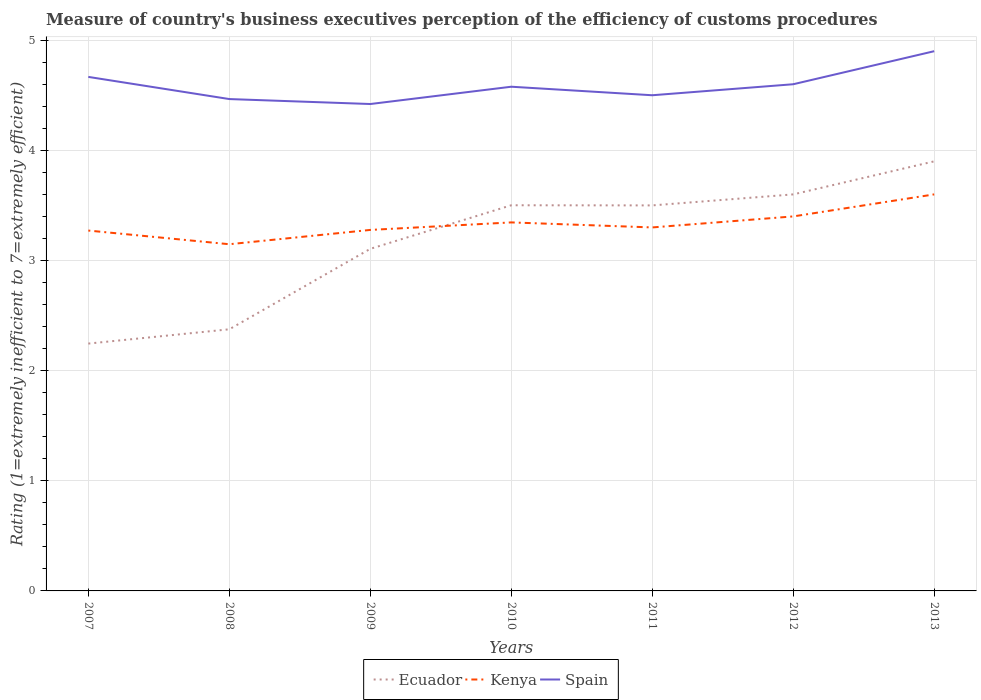How many different coloured lines are there?
Your answer should be compact. 3. Across all years, what is the maximum rating of the efficiency of customs procedure in Ecuador?
Your response must be concise. 2.25. What is the total rating of the efficiency of customs procedure in Spain in the graph?
Your answer should be compact. -0.02. What is the difference between the highest and the second highest rating of the efficiency of customs procedure in Spain?
Offer a very short reply. 0.48. Is the rating of the efficiency of customs procedure in Ecuador strictly greater than the rating of the efficiency of customs procedure in Spain over the years?
Keep it short and to the point. Yes. What is the difference between two consecutive major ticks on the Y-axis?
Provide a succinct answer. 1. Are the values on the major ticks of Y-axis written in scientific E-notation?
Your answer should be very brief. No. Does the graph contain any zero values?
Provide a succinct answer. No. Does the graph contain grids?
Make the answer very short. Yes. Where does the legend appear in the graph?
Provide a short and direct response. Bottom center. What is the title of the graph?
Provide a short and direct response. Measure of country's business executives perception of the efficiency of customs procedures. What is the label or title of the Y-axis?
Your answer should be very brief. Rating (1=extremely inefficient to 7=extremely efficient). What is the Rating (1=extremely inefficient to 7=extremely efficient) of Ecuador in 2007?
Give a very brief answer. 2.25. What is the Rating (1=extremely inefficient to 7=extremely efficient) in Kenya in 2007?
Your response must be concise. 3.27. What is the Rating (1=extremely inefficient to 7=extremely efficient) in Spain in 2007?
Your answer should be very brief. 4.67. What is the Rating (1=extremely inefficient to 7=extremely efficient) of Ecuador in 2008?
Provide a short and direct response. 2.38. What is the Rating (1=extremely inefficient to 7=extremely efficient) in Kenya in 2008?
Provide a succinct answer. 3.15. What is the Rating (1=extremely inefficient to 7=extremely efficient) of Spain in 2008?
Your answer should be very brief. 4.47. What is the Rating (1=extremely inefficient to 7=extremely efficient) of Ecuador in 2009?
Offer a very short reply. 3.11. What is the Rating (1=extremely inefficient to 7=extremely efficient) of Kenya in 2009?
Provide a succinct answer. 3.28. What is the Rating (1=extremely inefficient to 7=extremely efficient) in Spain in 2009?
Offer a very short reply. 4.42. What is the Rating (1=extremely inefficient to 7=extremely efficient) of Ecuador in 2010?
Your answer should be compact. 3.5. What is the Rating (1=extremely inefficient to 7=extremely efficient) of Kenya in 2010?
Your answer should be compact. 3.35. What is the Rating (1=extremely inefficient to 7=extremely efficient) of Spain in 2010?
Offer a very short reply. 4.58. What is the Rating (1=extremely inefficient to 7=extremely efficient) in Kenya in 2011?
Your answer should be very brief. 3.3. What is the Rating (1=extremely inefficient to 7=extremely efficient) of Spain in 2011?
Ensure brevity in your answer.  4.5. What is the Rating (1=extremely inefficient to 7=extremely efficient) in Ecuador in 2012?
Offer a very short reply. 3.6. What is the Rating (1=extremely inefficient to 7=extremely efficient) in Spain in 2013?
Your response must be concise. 4.9. Across all years, what is the maximum Rating (1=extremely inefficient to 7=extremely efficient) of Spain?
Provide a succinct answer. 4.9. Across all years, what is the minimum Rating (1=extremely inefficient to 7=extremely efficient) of Ecuador?
Make the answer very short. 2.25. Across all years, what is the minimum Rating (1=extremely inefficient to 7=extremely efficient) in Kenya?
Your answer should be compact. 3.15. Across all years, what is the minimum Rating (1=extremely inefficient to 7=extremely efficient) of Spain?
Your answer should be compact. 4.42. What is the total Rating (1=extremely inefficient to 7=extremely efficient) in Ecuador in the graph?
Your response must be concise. 22.23. What is the total Rating (1=extremely inefficient to 7=extremely efficient) of Kenya in the graph?
Your response must be concise. 23.34. What is the total Rating (1=extremely inefficient to 7=extremely efficient) in Spain in the graph?
Keep it short and to the point. 32.13. What is the difference between the Rating (1=extremely inefficient to 7=extremely efficient) in Ecuador in 2007 and that in 2008?
Offer a terse response. -0.13. What is the difference between the Rating (1=extremely inefficient to 7=extremely efficient) in Kenya in 2007 and that in 2008?
Your answer should be compact. 0.12. What is the difference between the Rating (1=extremely inefficient to 7=extremely efficient) of Spain in 2007 and that in 2008?
Provide a succinct answer. 0.2. What is the difference between the Rating (1=extremely inefficient to 7=extremely efficient) in Ecuador in 2007 and that in 2009?
Provide a short and direct response. -0.86. What is the difference between the Rating (1=extremely inefficient to 7=extremely efficient) of Kenya in 2007 and that in 2009?
Ensure brevity in your answer.  -0.01. What is the difference between the Rating (1=extremely inefficient to 7=extremely efficient) in Spain in 2007 and that in 2009?
Your answer should be compact. 0.25. What is the difference between the Rating (1=extremely inefficient to 7=extremely efficient) of Ecuador in 2007 and that in 2010?
Offer a very short reply. -1.26. What is the difference between the Rating (1=extremely inefficient to 7=extremely efficient) of Kenya in 2007 and that in 2010?
Your answer should be very brief. -0.07. What is the difference between the Rating (1=extremely inefficient to 7=extremely efficient) of Spain in 2007 and that in 2010?
Provide a succinct answer. 0.09. What is the difference between the Rating (1=extremely inefficient to 7=extremely efficient) in Ecuador in 2007 and that in 2011?
Your answer should be compact. -1.25. What is the difference between the Rating (1=extremely inefficient to 7=extremely efficient) of Kenya in 2007 and that in 2011?
Give a very brief answer. -0.03. What is the difference between the Rating (1=extremely inefficient to 7=extremely efficient) in Ecuador in 2007 and that in 2012?
Offer a terse response. -1.35. What is the difference between the Rating (1=extremely inefficient to 7=extremely efficient) in Kenya in 2007 and that in 2012?
Your answer should be compact. -0.13. What is the difference between the Rating (1=extremely inefficient to 7=extremely efficient) in Spain in 2007 and that in 2012?
Make the answer very short. 0.07. What is the difference between the Rating (1=extremely inefficient to 7=extremely efficient) of Ecuador in 2007 and that in 2013?
Ensure brevity in your answer.  -1.65. What is the difference between the Rating (1=extremely inefficient to 7=extremely efficient) of Kenya in 2007 and that in 2013?
Offer a very short reply. -0.33. What is the difference between the Rating (1=extremely inefficient to 7=extremely efficient) in Spain in 2007 and that in 2013?
Give a very brief answer. -0.23. What is the difference between the Rating (1=extremely inefficient to 7=extremely efficient) in Ecuador in 2008 and that in 2009?
Give a very brief answer. -0.73. What is the difference between the Rating (1=extremely inefficient to 7=extremely efficient) of Kenya in 2008 and that in 2009?
Offer a very short reply. -0.13. What is the difference between the Rating (1=extremely inefficient to 7=extremely efficient) of Spain in 2008 and that in 2009?
Ensure brevity in your answer.  0.05. What is the difference between the Rating (1=extremely inefficient to 7=extremely efficient) of Ecuador in 2008 and that in 2010?
Offer a very short reply. -1.13. What is the difference between the Rating (1=extremely inefficient to 7=extremely efficient) of Kenya in 2008 and that in 2010?
Offer a terse response. -0.2. What is the difference between the Rating (1=extremely inefficient to 7=extremely efficient) in Spain in 2008 and that in 2010?
Your response must be concise. -0.11. What is the difference between the Rating (1=extremely inefficient to 7=extremely efficient) in Ecuador in 2008 and that in 2011?
Keep it short and to the point. -1.12. What is the difference between the Rating (1=extremely inefficient to 7=extremely efficient) of Kenya in 2008 and that in 2011?
Ensure brevity in your answer.  -0.15. What is the difference between the Rating (1=extremely inefficient to 7=extremely efficient) in Spain in 2008 and that in 2011?
Offer a very short reply. -0.03. What is the difference between the Rating (1=extremely inefficient to 7=extremely efficient) in Ecuador in 2008 and that in 2012?
Your response must be concise. -1.22. What is the difference between the Rating (1=extremely inefficient to 7=extremely efficient) of Kenya in 2008 and that in 2012?
Offer a terse response. -0.25. What is the difference between the Rating (1=extremely inefficient to 7=extremely efficient) in Spain in 2008 and that in 2012?
Ensure brevity in your answer.  -0.13. What is the difference between the Rating (1=extremely inefficient to 7=extremely efficient) in Ecuador in 2008 and that in 2013?
Provide a succinct answer. -1.52. What is the difference between the Rating (1=extremely inefficient to 7=extremely efficient) in Kenya in 2008 and that in 2013?
Offer a terse response. -0.45. What is the difference between the Rating (1=extremely inefficient to 7=extremely efficient) of Spain in 2008 and that in 2013?
Make the answer very short. -0.43. What is the difference between the Rating (1=extremely inefficient to 7=extremely efficient) of Ecuador in 2009 and that in 2010?
Make the answer very short. -0.4. What is the difference between the Rating (1=extremely inefficient to 7=extremely efficient) in Kenya in 2009 and that in 2010?
Make the answer very short. -0.07. What is the difference between the Rating (1=extremely inefficient to 7=extremely efficient) of Spain in 2009 and that in 2010?
Offer a terse response. -0.16. What is the difference between the Rating (1=extremely inefficient to 7=extremely efficient) of Ecuador in 2009 and that in 2011?
Keep it short and to the point. -0.39. What is the difference between the Rating (1=extremely inefficient to 7=extremely efficient) of Kenya in 2009 and that in 2011?
Offer a terse response. -0.02. What is the difference between the Rating (1=extremely inefficient to 7=extremely efficient) of Spain in 2009 and that in 2011?
Make the answer very short. -0.08. What is the difference between the Rating (1=extremely inefficient to 7=extremely efficient) of Ecuador in 2009 and that in 2012?
Offer a terse response. -0.49. What is the difference between the Rating (1=extremely inefficient to 7=extremely efficient) in Kenya in 2009 and that in 2012?
Your response must be concise. -0.12. What is the difference between the Rating (1=extremely inefficient to 7=extremely efficient) in Spain in 2009 and that in 2012?
Ensure brevity in your answer.  -0.18. What is the difference between the Rating (1=extremely inefficient to 7=extremely efficient) of Ecuador in 2009 and that in 2013?
Provide a short and direct response. -0.79. What is the difference between the Rating (1=extremely inefficient to 7=extremely efficient) of Kenya in 2009 and that in 2013?
Provide a succinct answer. -0.32. What is the difference between the Rating (1=extremely inefficient to 7=extremely efficient) of Spain in 2009 and that in 2013?
Keep it short and to the point. -0.48. What is the difference between the Rating (1=extremely inefficient to 7=extremely efficient) in Ecuador in 2010 and that in 2011?
Make the answer very short. 0. What is the difference between the Rating (1=extremely inefficient to 7=extremely efficient) in Kenya in 2010 and that in 2011?
Give a very brief answer. 0.05. What is the difference between the Rating (1=extremely inefficient to 7=extremely efficient) in Spain in 2010 and that in 2011?
Offer a very short reply. 0.08. What is the difference between the Rating (1=extremely inefficient to 7=extremely efficient) in Ecuador in 2010 and that in 2012?
Provide a succinct answer. -0.1. What is the difference between the Rating (1=extremely inefficient to 7=extremely efficient) of Kenya in 2010 and that in 2012?
Ensure brevity in your answer.  -0.05. What is the difference between the Rating (1=extremely inefficient to 7=extremely efficient) of Spain in 2010 and that in 2012?
Provide a short and direct response. -0.02. What is the difference between the Rating (1=extremely inefficient to 7=extremely efficient) of Ecuador in 2010 and that in 2013?
Offer a terse response. -0.4. What is the difference between the Rating (1=extremely inefficient to 7=extremely efficient) of Kenya in 2010 and that in 2013?
Keep it short and to the point. -0.25. What is the difference between the Rating (1=extremely inefficient to 7=extremely efficient) in Spain in 2010 and that in 2013?
Your answer should be compact. -0.32. What is the difference between the Rating (1=extremely inefficient to 7=extremely efficient) in Spain in 2011 and that in 2012?
Keep it short and to the point. -0.1. What is the difference between the Rating (1=extremely inefficient to 7=extremely efficient) of Ecuador in 2011 and that in 2013?
Provide a succinct answer. -0.4. What is the difference between the Rating (1=extremely inefficient to 7=extremely efficient) of Kenya in 2011 and that in 2013?
Your response must be concise. -0.3. What is the difference between the Rating (1=extremely inefficient to 7=extremely efficient) of Kenya in 2012 and that in 2013?
Your answer should be very brief. -0.2. What is the difference between the Rating (1=extremely inefficient to 7=extremely efficient) of Spain in 2012 and that in 2013?
Make the answer very short. -0.3. What is the difference between the Rating (1=extremely inefficient to 7=extremely efficient) in Ecuador in 2007 and the Rating (1=extremely inefficient to 7=extremely efficient) in Kenya in 2008?
Your answer should be very brief. -0.9. What is the difference between the Rating (1=extremely inefficient to 7=extremely efficient) of Ecuador in 2007 and the Rating (1=extremely inefficient to 7=extremely efficient) of Spain in 2008?
Keep it short and to the point. -2.22. What is the difference between the Rating (1=extremely inefficient to 7=extremely efficient) in Kenya in 2007 and the Rating (1=extremely inefficient to 7=extremely efficient) in Spain in 2008?
Your answer should be very brief. -1.19. What is the difference between the Rating (1=extremely inefficient to 7=extremely efficient) of Ecuador in 2007 and the Rating (1=extremely inefficient to 7=extremely efficient) of Kenya in 2009?
Ensure brevity in your answer.  -1.03. What is the difference between the Rating (1=extremely inefficient to 7=extremely efficient) in Ecuador in 2007 and the Rating (1=extremely inefficient to 7=extremely efficient) in Spain in 2009?
Your response must be concise. -2.17. What is the difference between the Rating (1=extremely inefficient to 7=extremely efficient) of Kenya in 2007 and the Rating (1=extremely inefficient to 7=extremely efficient) of Spain in 2009?
Your answer should be compact. -1.15. What is the difference between the Rating (1=extremely inefficient to 7=extremely efficient) of Ecuador in 2007 and the Rating (1=extremely inefficient to 7=extremely efficient) of Kenya in 2010?
Give a very brief answer. -1.1. What is the difference between the Rating (1=extremely inefficient to 7=extremely efficient) in Ecuador in 2007 and the Rating (1=extremely inefficient to 7=extremely efficient) in Spain in 2010?
Make the answer very short. -2.33. What is the difference between the Rating (1=extremely inefficient to 7=extremely efficient) in Kenya in 2007 and the Rating (1=extremely inefficient to 7=extremely efficient) in Spain in 2010?
Offer a terse response. -1.31. What is the difference between the Rating (1=extremely inefficient to 7=extremely efficient) of Ecuador in 2007 and the Rating (1=extremely inefficient to 7=extremely efficient) of Kenya in 2011?
Provide a short and direct response. -1.05. What is the difference between the Rating (1=extremely inefficient to 7=extremely efficient) of Ecuador in 2007 and the Rating (1=extremely inefficient to 7=extremely efficient) of Spain in 2011?
Give a very brief answer. -2.25. What is the difference between the Rating (1=extremely inefficient to 7=extremely efficient) in Kenya in 2007 and the Rating (1=extremely inefficient to 7=extremely efficient) in Spain in 2011?
Make the answer very short. -1.23. What is the difference between the Rating (1=extremely inefficient to 7=extremely efficient) of Ecuador in 2007 and the Rating (1=extremely inefficient to 7=extremely efficient) of Kenya in 2012?
Ensure brevity in your answer.  -1.15. What is the difference between the Rating (1=extremely inefficient to 7=extremely efficient) in Ecuador in 2007 and the Rating (1=extremely inefficient to 7=extremely efficient) in Spain in 2012?
Keep it short and to the point. -2.35. What is the difference between the Rating (1=extremely inefficient to 7=extremely efficient) of Kenya in 2007 and the Rating (1=extremely inefficient to 7=extremely efficient) of Spain in 2012?
Provide a short and direct response. -1.33. What is the difference between the Rating (1=extremely inefficient to 7=extremely efficient) in Ecuador in 2007 and the Rating (1=extremely inefficient to 7=extremely efficient) in Kenya in 2013?
Your response must be concise. -1.35. What is the difference between the Rating (1=extremely inefficient to 7=extremely efficient) in Ecuador in 2007 and the Rating (1=extremely inefficient to 7=extremely efficient) in Spain in 2013?
Provide a short and direct response. -2.65. What is the difference between the Rating (1=extremely inefficient to 7=extremely efficient) in Kenya in 2007 and the Rating (1=extremely inefficient to 7=extremely efficient) in Spain in 2013?
Your answer should be compact. -1.63. What is the difference between the Rating (1=extremely inefficient to 7=extremely efficient) of Ecuador in 2008 and the Rating (1=extremely inefficient to 7=extremely efficient) of Kenya in 2009?
Your answer should be very brief. -0.9. What is the difference between the Rating (1=extremely inefficient to 7=extremely efficient) of Ecuador in 2008 and the Rating (1=extremely inefficient to 7=extremely efficient) of Spain in 2009?
Provide a short and direct response. -2.05. What is the difference between the Rating (1=extremely inefficient to 7=extremely efficient) in Kenya in 2008 and the Rating (1=extremely inefficient to 7=extremely efficient) in Spain in 2009?
Offer a terse response. -1.27. What is the difference between the Rating (1=extremely inefficient to 7=extremely efficient) in Ecuador in 2008 and the Rating (1=extremely inefficient to 7=extremely efficient) in Kenya in 2010?
Offer a terse response. -0.97. What is the difference between the Rating (1=extremely inefficient to 7=extremely efficient) of Ecuador in 2008 and the Rating (1=extremely inefficient to 7=extremely efficient) of Spain in 2010?
Your answer should be compact. -2.2. What is the difference between the Rating (1=extremely inefficient to 7=extremely efficient) of Kenya in 2008 and the Rating (1=extremely inefficient to 7=extremely efficient) of Spain in 2010?
Provide a succinct answer. -1.43. What is the difference between the Rating (1=extremely inefficient to 7=extremely efficient) in Ecuador in 2008 and the Rating (1=extremely inefficient to 7=extremely efficient) in Kenya in 2011?
Offer a terse response. -0.92. What is the difference between the Rating (1=extremely inefficient to 7=extremely efficient) of Ecuador in 2008 and the Rating (1=extremely inefficient to 7=extremely efficient) of Spain in 2011?
Your answer should be very brief. -2.12. What is the difference between the Rating (1=extremely inefficient to 7=extremely efficient) in Kenya in 2008 and the Rating (1=extremely inefficient to 7=extremely efficient) in Spain in 2011?
Ensure brevity in your answer.  -1.35. What is the difference between the Rating (1=extremely inefficient to 7=extremely efficient) of Ecuador in 2008 and the Rating (1=extremely inefficient to 7=extremely efficient) of Kenya in 2012?
Offer a very short reply. -1.02. What is the difference between the Rating (1=extremely inefficient to 7=extremely efficient) in Ecuador in 2008 and the Rating (1=extremely inefficient to 7=extremely efficient) in Spain in 2012?
Keep it short and to the point. -2.22. What is the difference between the Rating (1=extremely inefficient to 7=extremely efficient) in Kenya in 2008 and the Rating (1=extremely inefficient to 7=extremely efficient) in Spain in 2012?
Your answer should be very brief. -1.45. What is the difference between the Rating (1=extremely inefficient to 7=extremely efficient) in Ecuador in 2008 and the Rating (1=extremely inefficient to 7=extremely efficient) in Kenya in 2013?
Your answer should be very brief. -1.22. What is the difference between the Rating (1=extremely inefficient to 7=extremely efficient) of Ecuador in 2008 and the Rating (1=extremely inefficient to 7=extremely efficient) of Spain in 2013?
Offer a terse response. -2.52. What is the difference between the Rating (1=extremely inefficient to 7=extremely efficient) of Kenya in 2008 and the Rating (1=extremely inefficient to 7=extremely efficient) of Spain in 2013?
Your answer should be compact. -1.75. What is the difference between the Rating (1=extremely inefficient to 7=extremely efficient) in Ecuador in 2009 and the Rating (1=extremely inefficient to 7=extremely efficient) in Kenya in 2010?
Keep it short and to the point. -0.24. What is the difference between the Rating (1=extremely inefficient to 7=extremely efficient) of Ecuador in 2009 and the Rating (1=extremely inefficient to 7=extremely efficient) of Spain in 2010?
Give a very brief answer. -1.47. What is the difference between the Rating (1=extremely inefficient to 7=extremely efficient) in Kenya in 2009 and the Rating (1=extremely inefficient to 7=extremely efficient) in Spain in 2010?
Your response must be concise. -1.3. What is the difference between the Rating (1=extremely inefficient to 7=extremely efficient) of Ecuador in 2009 and the Rating (1=extremely inefficient to 7=extremely efficient) of Kenya in 2011?
Keep it short and to the point. -0.19. What is the difference between the Rating (1=extremely inefficient to 7=extremely efficient) of Ecuador in 2009 and the Rating (1=extremely inefficient to 7=extremely efficient) of Spain in 2011?
Your answer should be very brief. -1.39. What is the difference between the Rating (1=extremely inefficient to 7=extremely efficient) in Kenya in 2009 and the Rating (1=extremely inefficient to 7=extremely efficient) in Spain in 2011?
Provide a succinct answer. -1.22. What is the difference between the Rating (1=extremely inefficient to 7=extremely efficient) of Ecuador in 2009 and the Rating (1=extremely inefficient to 7=extremely efficient) of Kenya in 2012?
Keep it short and to the point. -0.29. What is the difference between the Rating (1=extremely inefficient to 7=extremely efficient) of Ecuador in 2009 and the Rating (1=extremely inefficient to 7=extremely efficient) of Spain in 2012?
Provide a short and direct response. -1.49. What is the difference between the Rating (1=extremely inefficient to 7=extremely efficient) of Kenya in 2009 and the Rating (1=extremely inefficient to 7=extremely efficient) of Spain in 2012?
Keep it short and to the point. -1.32. What is the difference between the Rating (1=extremely inefficient to 7=extremely efficient) in Ecuador in 2009 and the Rating (1=extremely inefficient to 7=extremely efficient) in Kenya in 2013?
Give a very brief answer. -0.49. What is the difference between the Rating (1=extremely inefficient to 7=extremely efficient) in Ecuador in 2009 and the Rating (1=extremely inefficient to 7=extremely efficient) in Spain in 2013?
Offer a terse response. -1.79. What is the difference between the Rating (1=extremely inefficient to 7=extremely efficient) in Kenya in 2009 and the Rating (1=extremely inefficient to 7=extremely efficient) in Spain in 2013?
Your answer should be compact. -1.62. What is the difference between the Rating (1=extremely inefficient to 7=extremely efficient) in Ecuador in 2010 and the Rating (1=extremely inefficient to 7=extremely efficient) in Kenya in 2011?
Keep it short and to the point. 0.2. What is the difference between the Rating (1=extremely inefficient to 7=extremely efficient) in Ecuador in 2010 and the Rating (1=extremely inefficient to 7=extremely efficient) in Spain in 2011?
Keep it short and to the point. -1. What is the difference between the Rating (1=extremely inefficient to 7=extremely efficient) of Kenya in 2010 and the Rating (1=extremely inefficient to 7=extremely efficient) of Spain in 2011?
Ensure brevity in your answer.  -1.15. What is the difference between the Rating (1=extremely inefficient to 7=extremely efficient) of Ecuador in 2010 and the Rating (1=extremely inefficient to 7=extremely efficient) of Kenya in 2012?
Offer a very short reply. 0.1. What is the difference between the Rating (1=extremely inefficient to 7=extremely efficient) of Ecuador in 2010 and the Rating (1=extremely inefficient to 7=extremely efficient) of Spain in 2012?
Offer a very short reply. -1.1. What is the difference between the Rating (1=extremely inefficient to 7=extremely efficient) of Kenya in 2010 and the Rating (1=extremely inefficient to 7=extremely efficient) of Spain in 2012?
Your answer should be very brief. -1.25. What is the difference between the Rating (1=extremely inefficient to 7=extremely efficient) of Ecuador in 2010 and the Rating (1=extremely inefficient to 7=extremely efficient) of Kenya in 2013?
Give a very brief answer. -0.1. What is the difference between the Rating (1=extremely inefficient to 7=extremely efficient) of Ecuador in 2010 and the Rating (1=extremely inefficient to 7=extremely efficient) of Spain in 2013?
Keep it short and to the point. -1.4. What is the difference between the Rating (1=extremely inefficient to 7=extremely efficient) of Kenya in 2010 and the Rating (1=extremely inefficient to 7=extremely efficient) of Spain in 2013?
Your answer should be very brief. -1.55. What is the difference between the Rating (1=extremely inefficient to 7=extremely efficient) of Ecuador in 2011 and the Rating (1=extremely inefficient to 7=extremely efficient) of Kenya in 2012?
Offer a very short reply. 0.1. What is the difference between the Rating (1=extremely inefficient to 7=extremely efficient) in Ecuador in 2011 and the Rating (1=extremely inefficient to 7=extremely efficient) in Spain in 2013?
Make the answer very short. -1.4. What is the difference between the Rating (1=extremely inefficient to 7=extremely efficient) in Kenya in 2011 and the Rating (1=extremely inefficient to 7=extremely efficient) in Spain in 2013?
Keep it short and to the point. -1.6. What is the difference between the Rating (1=extremely inefficient to 7=extremely efficient) in Ecuador in 2012 and the Rating (1=extremely inefficient to 7=extremely efficient) in Spain in 2013?
Your answer should be very brief. -1.3. What is the difference between the Rating (1=extremely inefficient to 7=extremely efficient) of Kenya in 2012 and the Rating (1=extremely inefficient to 7=extremely efficient) of Spain in 2013?
Offer a very short reply. -1.5. What is the average Rating (1=extremely inefficient to 7=extremely efficient) of Ecuador per year?
Offer a terse response. 3.18. What is the average Rating (1=extremely inefficient to 7=extremely efficient) in Kenya per year?
Make the answer very short. 3.33. What is the average Rating (1=extremely inefficient to 7=extremely efficient) of Spain per year?
Your answer should be very brief. 4.59. In the year 2007, what is the difference between the Rating (1=extremely inefficient to 7=extremely efficient) of Ecuador and Rating (1=extremely inefficient to 7=extremely efficient) of Kenya?
Your answer should be very brief. -1.03. In the year 2007, what is the difference between the Rating (1=extremely inefficient to 7=extremely efficient) in Ecuador and Rating (1=extremely inefficient to 7=extremely efficient) in Spain?
Ensure brevity in your answer.  -2.42. In the year 2007, what is the difference between the Rating (1=extremely inefficient to 7=extremely efficient) in Kenya and Rating (1=extremely inefficient to 7=extremely efficient) in Spain?
Provide a succinct answer. -1.39. In the year 2008, what is the difference between the Rating (1=extremely inefficient to 7=extremely efficient) in Ecuador and Rating (1=extremely inefficient to 7=extremely efficient) in Kenya?
Your answer should be very brief. -0.77. In the year 2008, what is the difference between the Rating (1=extremely inefficient to 7=extremely efficient) in Ecuador and Rating (1=extremely inefficient to 7=extremely efficient) in Spain?
Provide a short and direct response. -2.09. In the year 2008, what is the difference between the Rating (1=extremely inefficient to 7=extremely efficient) of Kenya and Rating (1=extremely inefficient to 7=extremely efficient) of Spain?
Provide a short and direct response. -1.32. In the year 2009, what is the difference between the Rating (1=extremely inefficient to 7=extremely efficient) of Ecuador and Rating (1=extremely inefficient to 7=extremely efficient) of Kenya?
Make the answer very short. -0.17. In the year 2009, what is the difference between the Rating (1=extremely inefficient to 7=extremely efficient) in Ecuador and Rating (1=extremely inefficient to 7=extremely efficient) in Spain?
Your response must be concise. -1.31. In the year 2009, what is the difference between the Rating (1=extremely inefficient to 7=extremely efficient) of Kenya and Rating (1=extremely inefficient to 7=extremely efficient) of Spain?
Your answer should be very brief. -1.14. In the year 2010, what is the difference between the Rating (1=extremely inefficient to 7=extremely efficient) in Ecuador and Rating (1=extremely inefficient to 7=extremely efficient) in Kenya?
Provide a succinct answer. 0.16. In the year 2010, what is the difference between the Rating (1=extremely inefficient to 7=extremely efficient) in Ecuador and Rating (1=extremely inefficient to 7=extremely efficient) in Spain?
Your answer should be compact. -1.08. In the year 2010, what is the difference between the Rating (1=extremely inefficient to 7=extremely efficient) of Kenya and Rating (1=extremely inefficient to 7=extremely efficient) of Spain?
Offer a very short reply. -1.23. In the year 2011, what is the difference between the Rating (1=extremely inefficient to 7=extremely efficient) in Ecuador and Rating (1=extremely inefficient to 7=extremely efficient) in Kenya?
Your answer should be very brief. 0.2. In the year 2011, what is the difference between the Rating (1=extremely inefficient to 7=extremely efficient) of Kenya and Rating (1=extremely inefficient to 7=extremely efficient) of Spain?
Offer a very short reply. -1.2. In the year 2012, what is the difference between the Rating (1=extremely inefficient to 7=extremely efficient) of Ecuador and Rating (1=extremely inefficient to 7=extremely efficient) of Kenya?
Give a very brief answer. 0.2. In the year 2012, what is the difference between the Rating (1=extremely inefficient to 7=extremely efficient) in Ecuador and Rating (1=extremely inefficient to 7=extremely efficient) in Spain?
Ensure brevity in your answer.  -1. In the year 2012, what is the difference between the Rating (1=extremely inefficient to 7=extremely efficient) in Kenya and Rating (1=extremely inefficient to 7=extremely efficient) in Spain?
Provide a succinct answer. -1.2. In the year 2013, what is the difference between the Rating (1=extremely inefficient to 7=extremely efficient) in Kenya and Rating (1=extremely inefficient to 7=extremely efficient) in Spain?
Offer a terse response. -1.3. What is the ratio of the Rating (1=extremely inefficient to 7=extremely efficient) in Ecuador in 2007 to that in 2008?
Your response must be concise. 0.95. What is the ratio of the Rating (1=extremely inefficient to 7=extremely efficient) of Kenya in 2007 to that in 2008?
Your answer should be very brief. 1.04. What is the ratio of the Rating (1=extremely inefficient to 7=extremely efficient) of Spain in 2007 to that in 2008?
Your answer should be compact. 1.05. What is the ratio of the Rating (1=extremely inefficient to 7=extremely efficient) in Ecuador in 2007 to that in 2009?
Keep it short and to the point. 0.72. What is the ratio of the Rating (1=extremely inefficient to 7=extremely efficient) in Spain in 2007 to that in 2009?
Provide a short and direct response. 1.06. What is the ratio of the Rating (1=extremely inefficient to 7=extremely efficient) of Ecuador in 2007 to that in 2010?
Keep it short and to the point. 0.64. What is the ratio of the Rating (1=extremely inefficient to 7=extremely efficient) of Kenya in 2007 to that in 2010?
Offer a terse response. 0.98. What is the ratio of the Rating (1=extremely inefficient to 7=extremely efficient) of Spain in 2007 to that in 2010?
Provide a succinct answer. 1.02. What is the ratio of the Rating (1=extremely inefficient to 7=extremely efficient) of Ecuador in 2007 to that in 2011?
Ensure brevity in your answer.  0.64. What is the ratio of the Rating (1=extremely inefficient to 7=extremely efficient) in Kenya in 2007 to that in 2011?
Offer a terse response. 0.99. What is the ratio of the Rating (1=extremely inefficient to 7=extremely efficient) of Ecuador in 2007 to that in 2012?
Keep it short and to the point. 0.62. What is the ratio of the Rating (1=extremely inefficient to 7=extremely efficient) in Kenya in 2007 to that in 2012?
Provide a succinct answer. 0.96. What is the ratio of the Rating (1=extremely inefficient to 7=extremely efficient) of Spain in 2007 to that in 2012?
Ensure brevity in your answer.  1.01. What is the ratio of the Rating (1=extremely inefficient to 7=extremely efficient) of Ecuador in 2007 to that in 2013?
Keep it short and to the point. 0.58. What is the ratio of the Rating (1=extremely inefficient to 7=extremely efficient) in Kenya in 2007 to that in 2013?
Offer a very short reply. 0.91. What is the ratio of the Rating (1=extremely inefficient to 7=extremely efficient) of Ecuador in 2008 to that in 2009?
Provide a short and direct response. 0.76. What is the ratio of the Rating (1=extremely inefficient to 7=extremely efficient) in Kenya in 2008 to that in 2009?
Make the answer very short. 0.96. What is the ratio of the Rating (1=extremely inefficient to 7=extremely efficient) of Spain in 2008 to that in 2009?
Keep it short and to the point. 1.01. What is the ratio of the Rating (1=extremely inefficient to 7=extremely efficient) of Ecuador in 2008 to that in 2010?
Ensure brevity in your answer.  0.68. What is the ratio of the Rating (1=extremely inefficient to 7=extremely efficient) of Kenya in 2008 to that in 2010?
Give a very brief answer. 0.94. What is the ratio of the Rating (1=extremely inefficient to 7=extremely efficient) in Spain in 2008 to that in 2010?
Give a very brief answer. 0.98. What is the ratio of the Rating (1=extremely inefficient to 7=extremely efficient) of Ecuador in 2008 to that in 2011?
Provide a succinct answer. 0.68. What is the ratio of the Rating (1=extremely inefficient to 7=extremely efficient) of Kenya in 2008 to that in 2011?
Your answer should be compact. 0.95. What is the ratio of the Rating (1=extremely inefficient to 7=extremely efficient) in Ecuador in 2008 to that in 2012?
Provide a short and direct response. 0.66. What is the ratio of the Rating (1=extremely inefficient to 7=extremely efficient) in Kenya in 2008 to that in 2012?
Offer a very short reply. 0.93. What is the ratio of the Rating (1=extremely inefficient to 7=extremely efficient) of Spain in 2008 to that in 2012?
Give a very brief answer. 0.97. What is the ratio of the Rating (1=extremely inefficient to 7=extremely efficient) in Ecuador in 2008 to that in 2013?
Keep it short and to the point. 0.61. What is the ratio of the Rating (1=extremely inefficient to 7=extremely efficient) in Kenya in 2008 to that in 2013?
Provide a succinct answer. 0.87. What is the ratio of the Rating (1=extremely inefficient to 7=extremely efficient) of Spain in 2008 to that in 2013?
Provide a short and direct response. 0.91. What is the ratio of the Rating (1=extremely inefficient to 7=extremely efficient) in Ecuador in 2009 to that in 2010?
Keep it short and to the point. 0.89. What is the ratio of the Rating (1=extremely inefficient to 7=extremely efficient) of Kenya in 2009 to that in 2010?
Provide a succinct answer. 0.98. What is the ratio of the Rating (1=extremely inefficient to 7=extremely efficient) in Spain in 2009 to that in 2010?
Your answer should be very brief. 0.97. What is the ratio of the Rating (1=extremely inefficient to 7=extremely efficient) in Ecuador in 2009 to that in 2011?
Keep it short and to the point. 0.89. What is the ratio of the Rating (1=extremely inefficient to 7=extremely efficient) in Kenya in 2009 to that in 2011?
Keep it short and to the point. 0.99. What is the ratio of the Rating (1=extremely inefficient to 7=extremely efficient) in Spain in 2009 to that in 2011?
Your response must be concise. 0.98. What is the ratio of the Rating (1=extremely inefficient to 7=extremely efficient) in Ecuador in 2009 to that in 2012?
Offer a very short reply. 0.86. What is the ratio of the Rating (1=extremely inefficient to 7=extremely efficient) of Kenya in 2009 to that in 2012?
Your answer should be compact. 0.96. What is the ratio of the Rating (1=extremely inefficient to 7=extremely efficient) in Spain in 2009 to that in 2012?
Give a very brief answer. 0.96. What is the ratio of the Rating (1=extremely inefficient to 7=extremely efficient) in Ecuador in 2009 to that in 2013?
Provide a short and direct response. 0.8. What is the ratio of the Rating (1=extremely inefficient to 7=extremely efficient) in Kenya in 2009 to that in 2013?
Your answer should be very brief. 0.91. What is the ratio of the Rating (1=extremely inefficient to 7=extremely efficient) in Spain in 2009 to that in 2013?
Make the answer very short. 0.9. What is the ratio of the Rating (1=extremely inefficient to 7=extremely efficient) in Ecuador in 2010 to that in 2011?
Provide a short and direct response. 1. What is the ratio of the Rating (1=extremely inefficient to 7=extremely efficient) of Kenya in 2010 to that in 2011?
Ensure brevity in your answer.  1.01. What is the ratio of the Rating (1=extremely inefficient to 7=extremely efficient) of Spain in 2010 to that in 2011?
Provide a succinct answer. 1.02. What is the ratio of the Rating (1=extremely inefficient to 7=extremely efficient) in Ecuador in 2010 to that in 2012?
Give a very brief answer. 0.97. What is the ratio of the Rating (1=extremely inefficient to 7=extremely efficient) of Kenya in 2010 to that in 2012?
Your answer should be compact. 0.98. What is the ratio of the Rating (1=extremely inefficient to 7=extremely efficient) in Ecuador in 2010 to that in 2013?
Make the answer very short. 0.9. What is the ratio of the Rating (1=extremely inefficient to 7=extremely efficient) of Kenya in 2010 to that in 2013?
Provide a succinct answer. 0.93. What is the ratio of the Rating (1=extremely inefficient to 7=extremely efficient) in Spain in 2010 to that in 2013?
Offer a terse response. 0.93. What is the ratio of the Rating (1=extremely inefficient to 7=extremely efficient) in Ecuador in 2011 to that in 2012?
Offer a terse response. 0.97. What is the ratio of the Rating (1=extremely inefficient to 7=extremely efficient) of Kenya in 2011 to that in 2012?
Ensure brevity in your answer.  0.97. What is the ratio of the Rating (1=extremely inefficient to 7=extremely efficient) in Spain in 2011 to that in 2012?
Offer a terse response. 0.98. What is the ratio of the Rating (1=extremely inefficient to 7=extremely efficient) in Ecuador in 2011 to that in 2013?
Ensure brevity in your answer.  0.9. What is the ratio of the Rating (1=extremely inefficient to 7=extremely efficient) in Spain in 2011 to that in 2013?
Ensure brevity in your answer.  0.92. What is the ratio of the Rating (1=extremely inefficient to 7=extremely efficient) of Spain in 2012 to that in 2013?
Provide a succinct answer. 0.94. What is the difference between the highest and the second highest Rating (1=extremely inefficient to 7=extremely efficient) in Ecuador?
Make the answer very short. 0.3. What is the difference between the highest and the second highest Rating (1=extremely inefficient to 7=extremely efficient) in Kenya?
Offer a terse response. 0.2. What is the difference between the highest and the second highest Rating (1=extremely inefficient to 7=extremely efficient) in Spain?
Provide a short and direct response. 0.23. What is the difference between the highest and the lowest Rating (1=extremely inefficient to 7=extremely efficient) of Ecuador?
Provide a succinct answer. 1.65. What is the difference between the highest and the lowest Rating (1=extremely inefficient to 7=extremely efficient) of Kenya?
Offer a very short reply. 0.45. What is the difference between the highest and the lowest Rating (1=extremely inefficient to 7=extremely efficient) of Spain?
Make the answer very short. 0.48. 